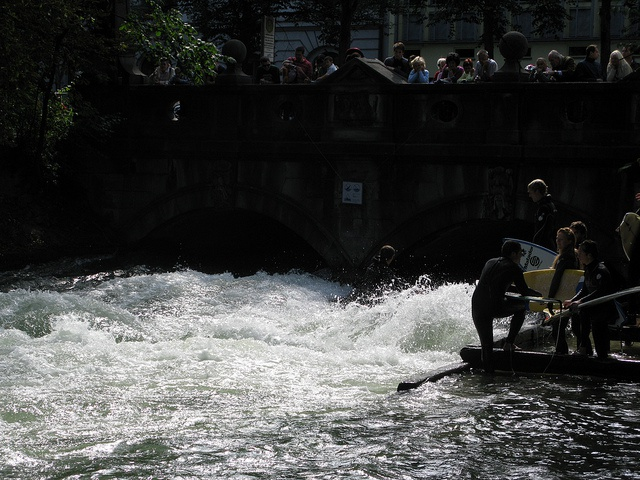Describe the objects in this image and their specific colors. I can see people in black and gray tones, people in black, gray, darkgray, and lightgray tones, people in black, gray, maroon, and darkgray tones, people in black and gray tones, and people in black, gray, darkgray, and beige tones in this image. 